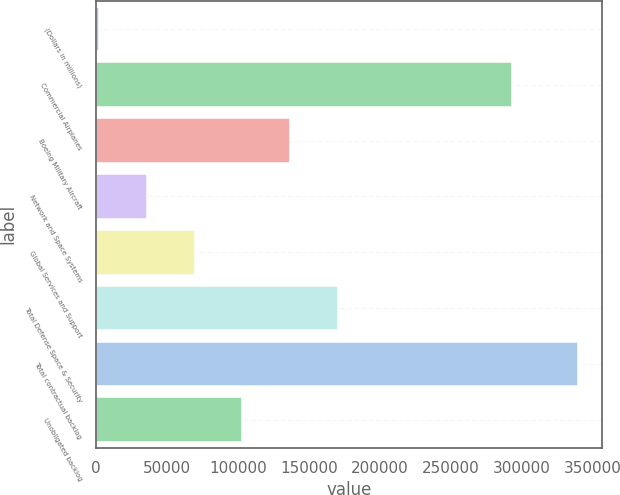Convert chart. <chart><loc_0><loc_0><loc_500><loc_500><bar_chart><fcel>(Dollars in millions)<fcel>Commercial Airplanes<fcel>Boeing Military Aircraft<fcel>Network and Space Systems<fcel>Global Services and Support<fcel>Total Defense Space & Security<fcel>Total contractual backlog<fcel>Unobligated backlog<nl><fcel>2011<fcel>293303<fcel>137069<fcel>35775.6<fcel>69540.2<fcel>170834<fcel>339657<fcel>103305<nl></chart> 